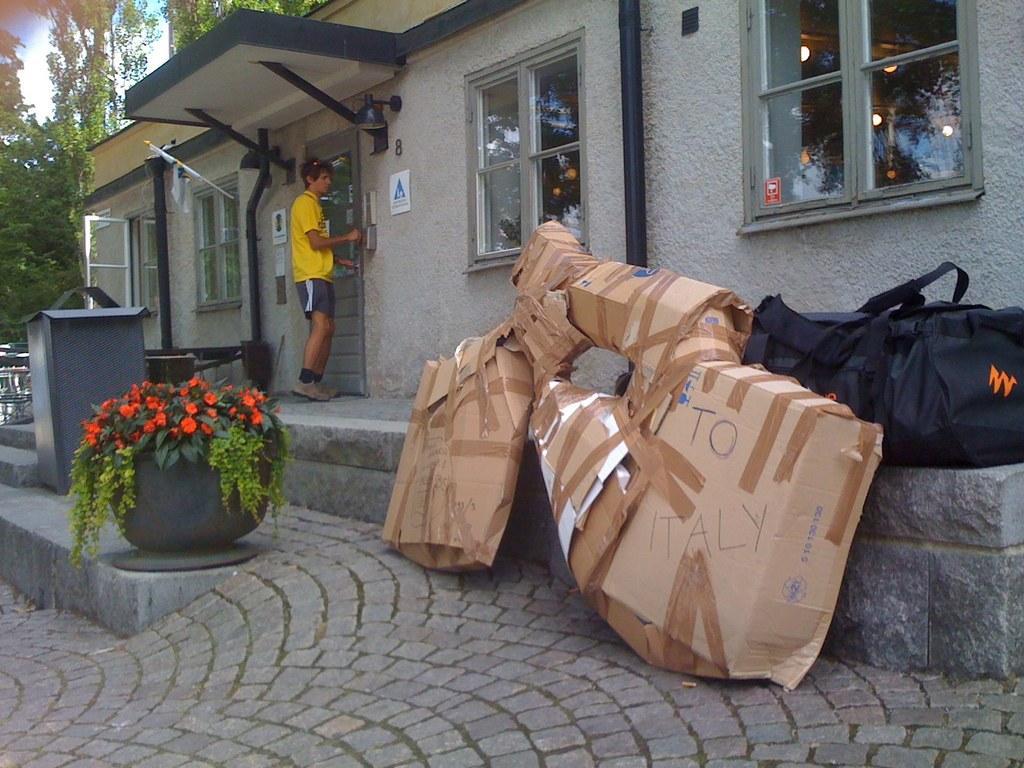In one or two sentences, can you explain what this image depicts? In this image we can see cobblestones, plant to which some flowers are grown, there are some items packed in the cardboard box and black color bag there is a person wearing yellow color T-shirt knocking on door and in the background of the image there is a house and some trees. 